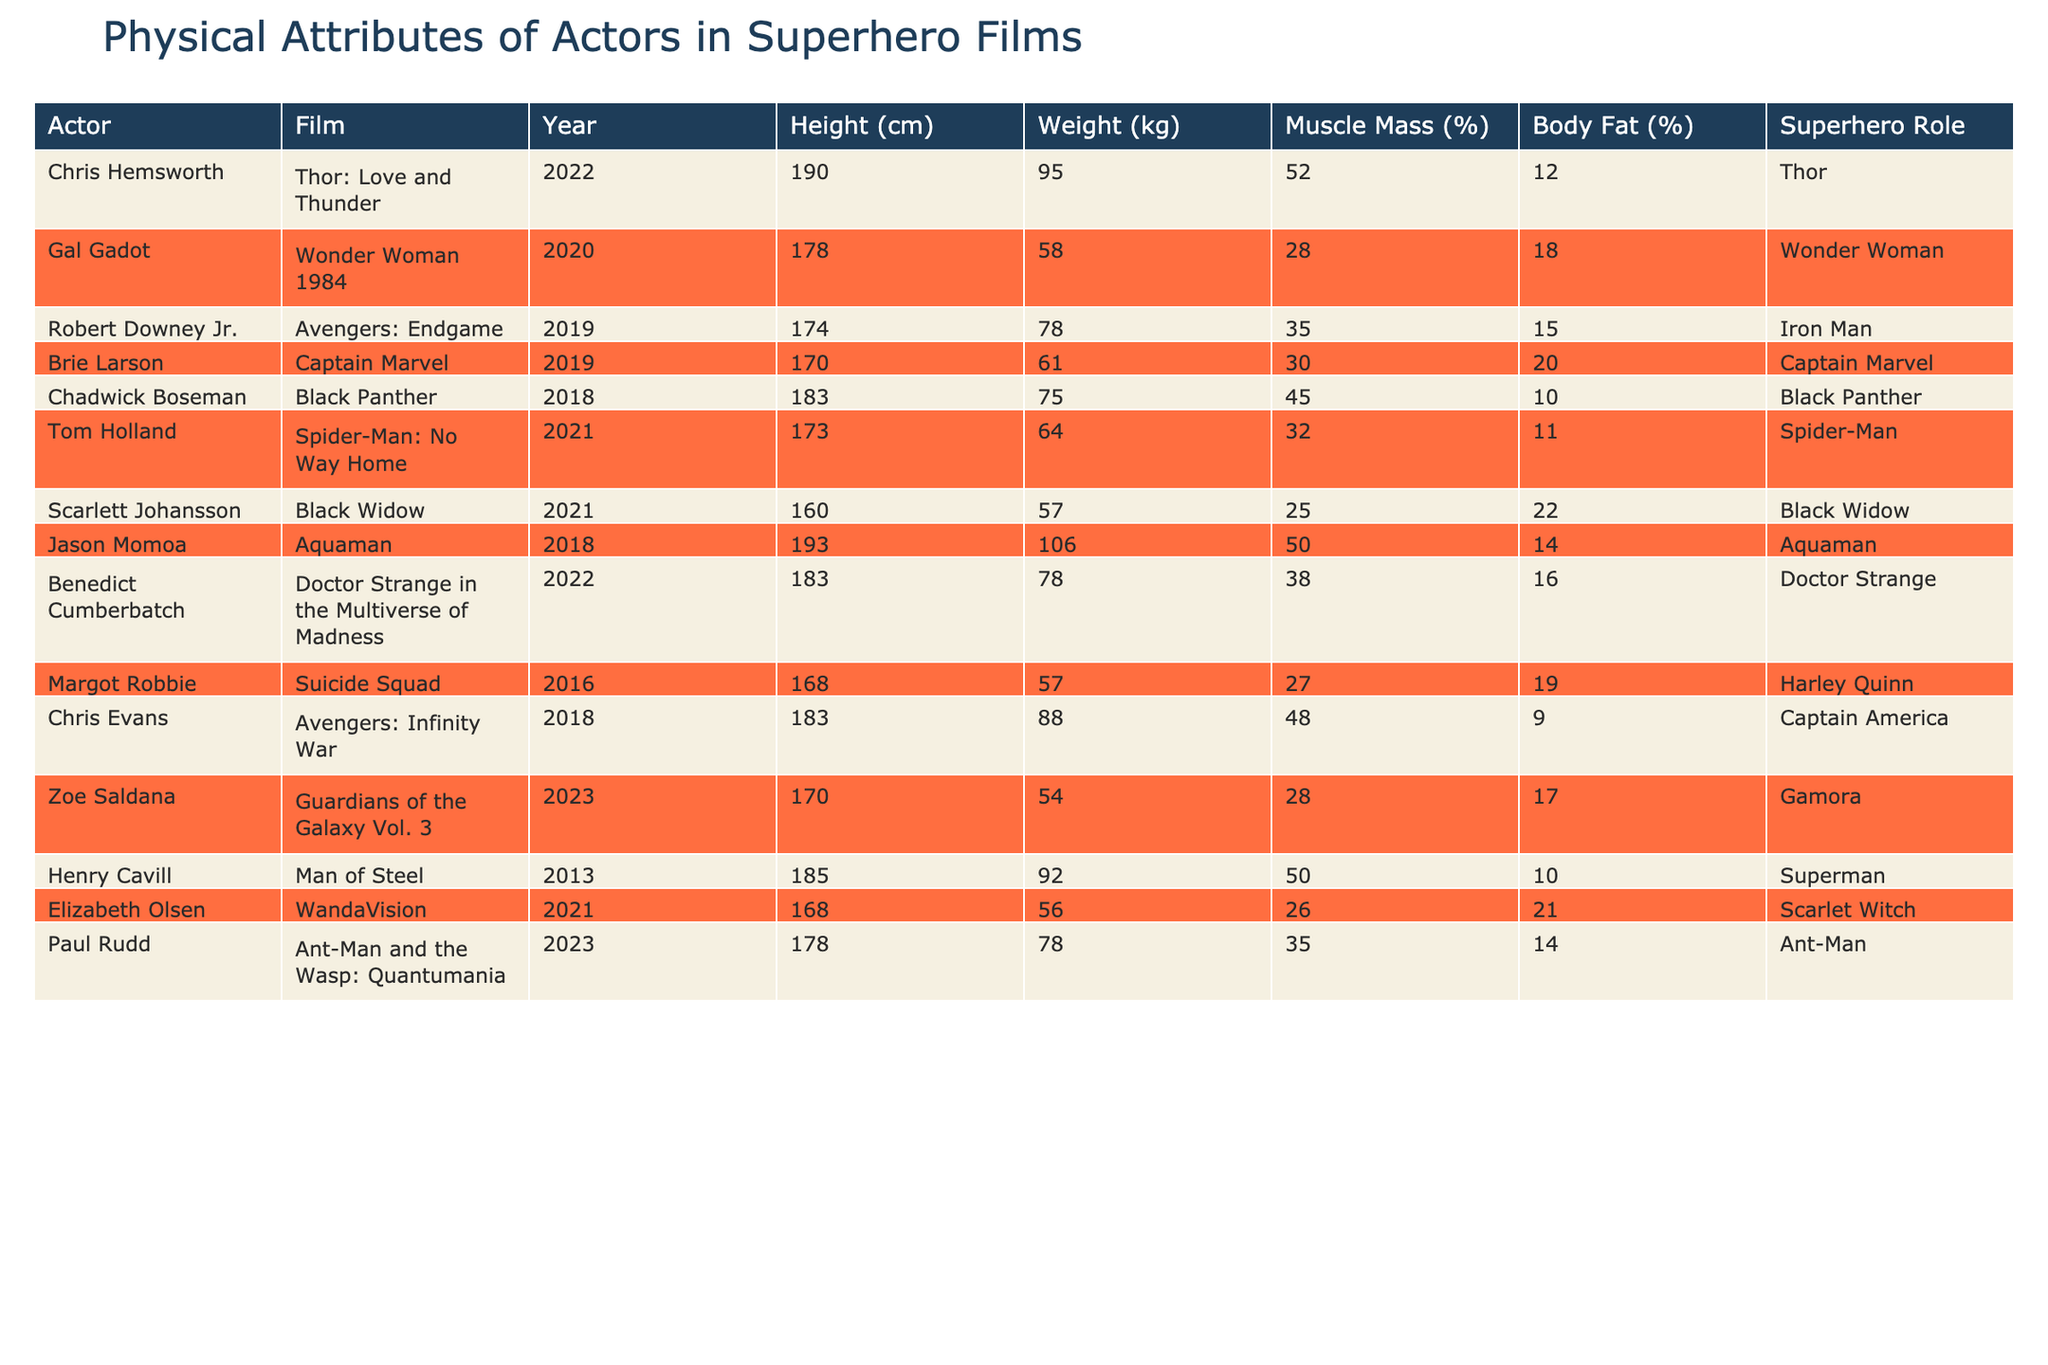What is the height of Gal Gadot? From the table, I can see that Gal Gadot has a height of 178 cm listed.
Answer: 178 cm Which actor has the highest weight? By reviewing the weight column, Jason Momoa has the highest weight of 106 kg.
Answer: 106 kg What is the average height of the actors in this table? The heights are 190, 178, 174, 170, 183, 173, 160, 193, 183, 168, 183, 170, 185, 168, 178 cm. Summing these heights gives 2618 cm. There are 15 actors, so the average height is 2618/15 = 174.53 cm.
Answer: 174.53 cm Is Scarlett Johansson taller than Tom Holland? Scarlett Johansson is 160 cm tall and Tom Holland is 173 cm tall. Therefore, Scarlett is not taller than Tom.
Answer: No Who plays the character with the lowest body fat percentage? Reviewing the body fat percentages, Scarlett Johansson has 22%, which is the highest, but Chadwick Boseman has 10%, which is the lowest. Thus, he has the lowest body fat percentage.
Answer: Chadwick Boseman What is the total muscle mass percentage of Chris Hemsworth and Chris Evans combined? Chris Hemsworth has a muscle mass percentage of 52% and Chris Evans has 48%. Adding these together gives 52 + 48 = 100%.
Answer: 100% Is there a superhero actor with a height less than 165 cm? Looking through the height column, the lowest height recorded is 160 cm for Scarlett Johansson. Therefore, there is an actor below that height.
Answer: Yes Which actor has the same muscle mass percentage as Robert Downey Jr.? Robert Downey Jr. has a muscle mass percentage of 35%. Checking the table, Paul Rudd also has the same percentage of 35%.
Answer: Paul Rudd How many actors weigh more than 80 kg? The actors weighing over 80 kg are Chris Hemsworth (95 kg), Jason Momoa (106 kg), and Chris Evans (88 kg). This gives us a total of 3 actors.
Answer: 3 What is the relationship between height and body fat percentage among the listed actors? Observing the data, the tallest actor, Jason Momoa, has a body fat percentage of 14%, while the shortest, Scarlett Johansson, has 22%. This suggests that taller actors tend to have lower body fat percentages in this dataset.
Answer: Taller actors tend to have lower body fat percentages 